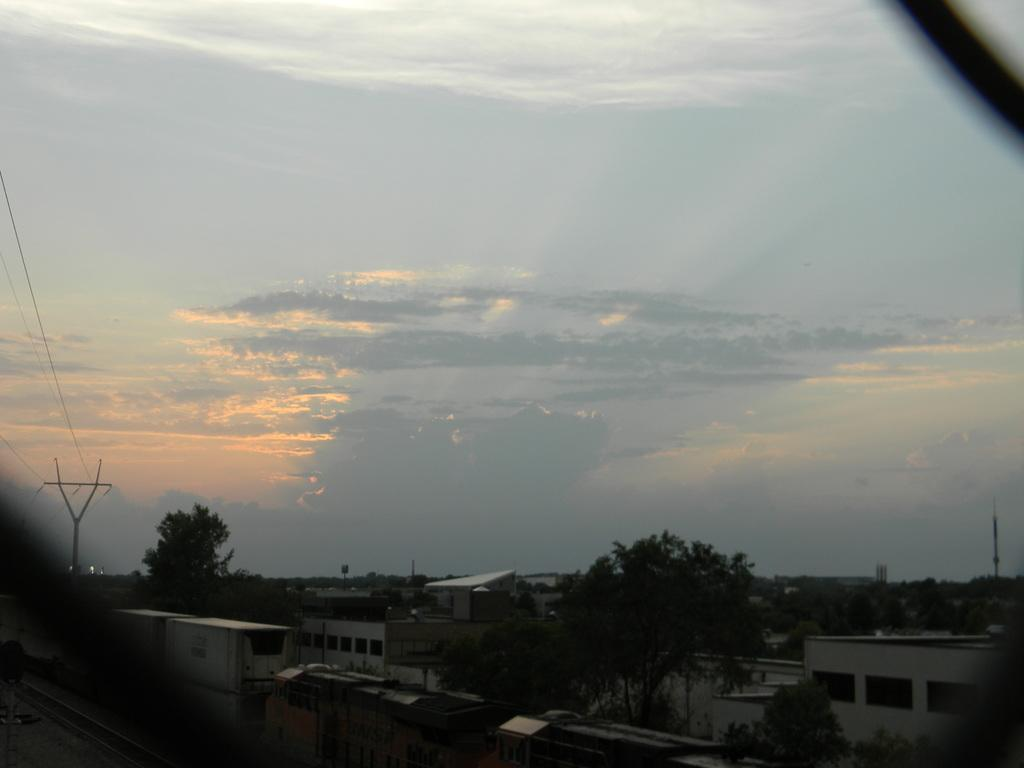What type of structures can be seen in the image? There are buildings, sheds, and towers in the image. What type of vegetation is present in the image? There are trees in the image. What man-made objects can be seen in the image? There are electric poles and electric cables in the image. What is visible in the sky in the image? The sky is visible in the image, and there are clouds present. Can you tell me how many times the rod was dropped in the image? There is no rod present in the image, so it is not possible to determine how many times it was dropped. What type of attack is being carried out in the image? There is no attack or any indication of violence in the image; it features buildings, sheds, trees, towers, electric poles, electric cables, and a sky with clouds. 